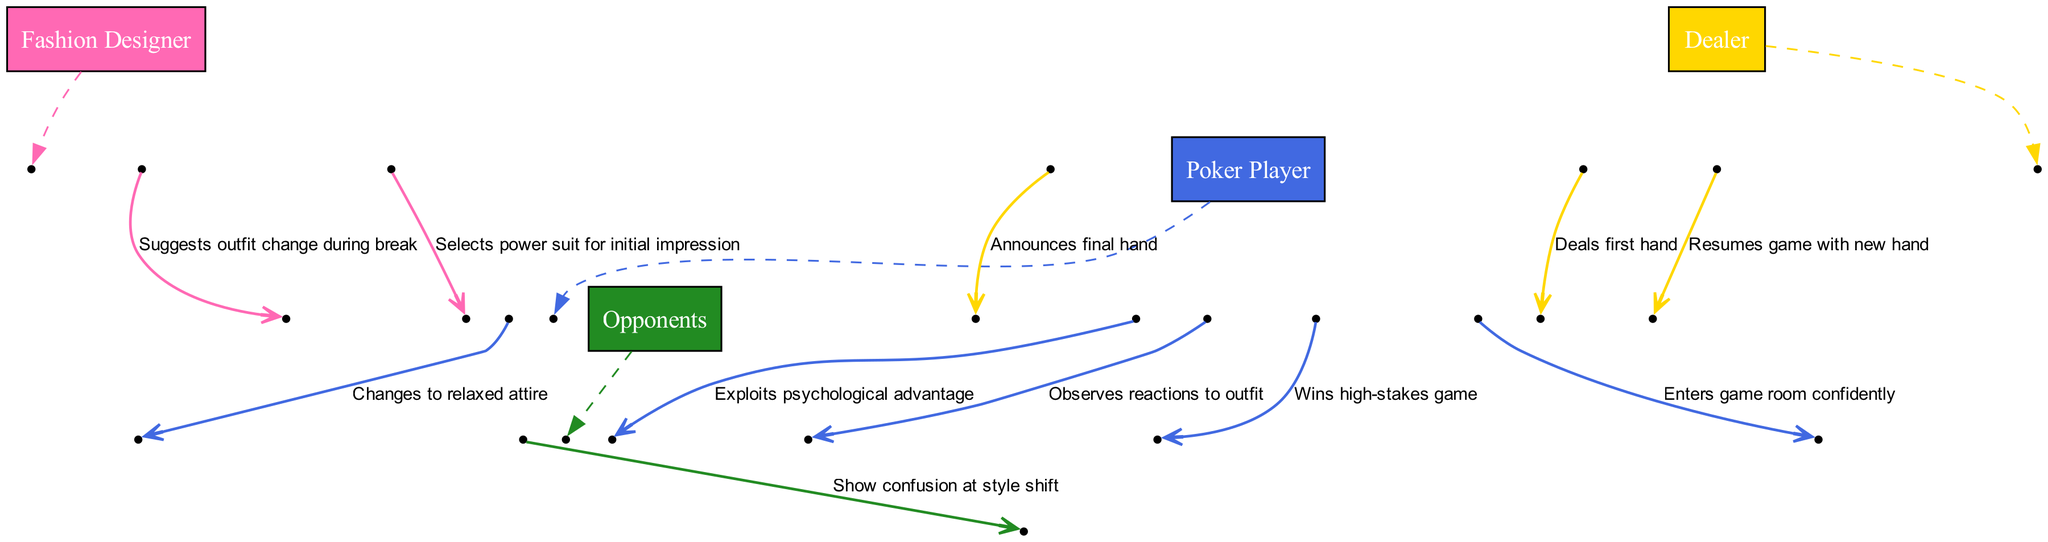What is the first message in the sequence? The first message is sent from the Fashion Designer to the Poker Player, indicating the choice of a power suit for creating an initial impression.
Answer: Selects power suit for initial impression Who does the Poker Player observe reactions from? The Poker Player observes the reactions to their outfit from the Opponents during the game.
Answer: Opponents What outfit does the Poker Player change into? The Poker Player changes into relaxed attire as suggested by the Fashion Designer during the break in the game.
Answer: Relaxed attire How many messages does the Dealer send in total? The Dealer sends a total of three messages throughout the sequence, including dealing the first hand, resuming the game with a new hand, and announcing the final hand.
Answer: Three What psychological advantage is exploited after the outfit change? After the outfit change to relaxed attire, the Poker Player exploits the psychological advantage gained from the Opponents' confusion regarding the style shift.
Answer: Psychological advantage Which actor suggests an outfit change? The suggestion for an outfit change during a break is made by the Fashion Designer to the Poker Player.
Answer: Fashion Designer What do the Opponents show in response to the style shift? The Opponents display confusion in response to the Poker Player’s outfit change during the game.
Answer: Confusion What does the Dealer do after the Poker Player changes outfits? After the Poker Player changes to relaxed attire, the Dealer resumes the game by dealing a new hand to the Poker Player.
Answer: Resumes game with new hand 